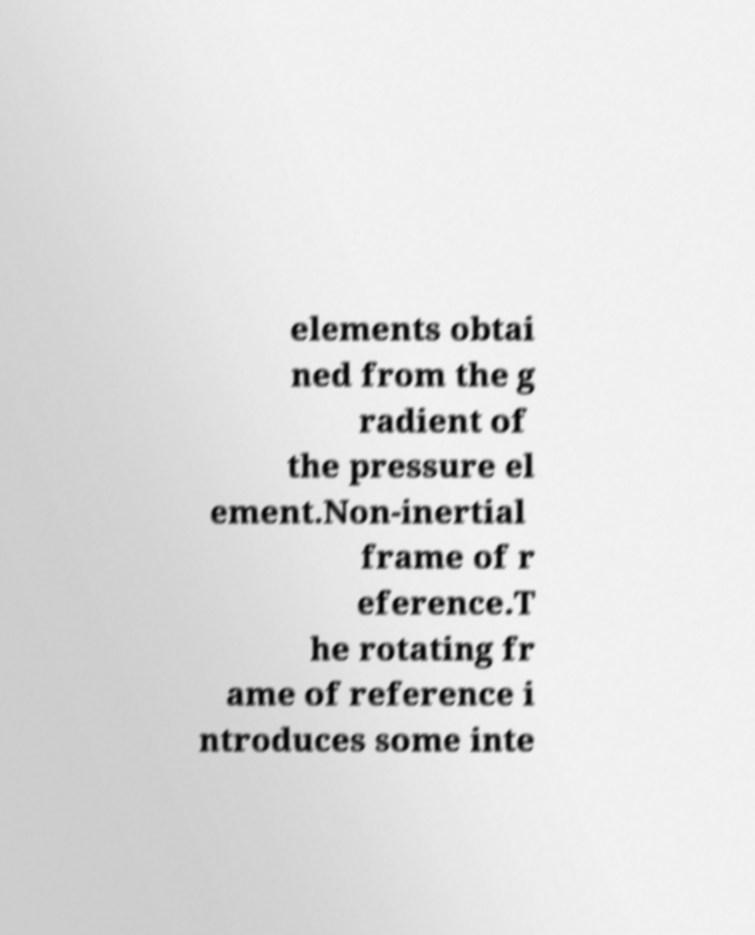For documentation purposes, I need the text within this image transcribed. Could you provide that? elements obtai ned from the g radient of the pressure el ement.Non-inertial frame of r eference.T he rotating fr ame of reference i ntroduces some inte 